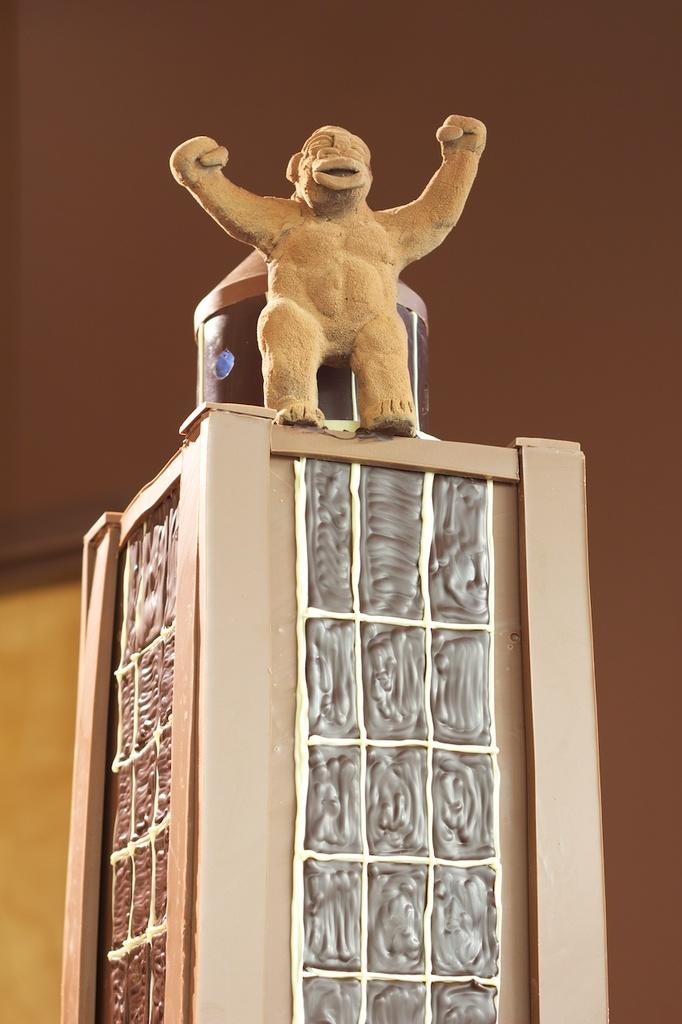What is the main subject in the center of the image? There is a statue in the center of the image. What can be seen in the background of the image? There is a wall in the background of the image. How much money is the expert holding in the image? There is no expert or money present in the image; it only features a statue and a wall. 